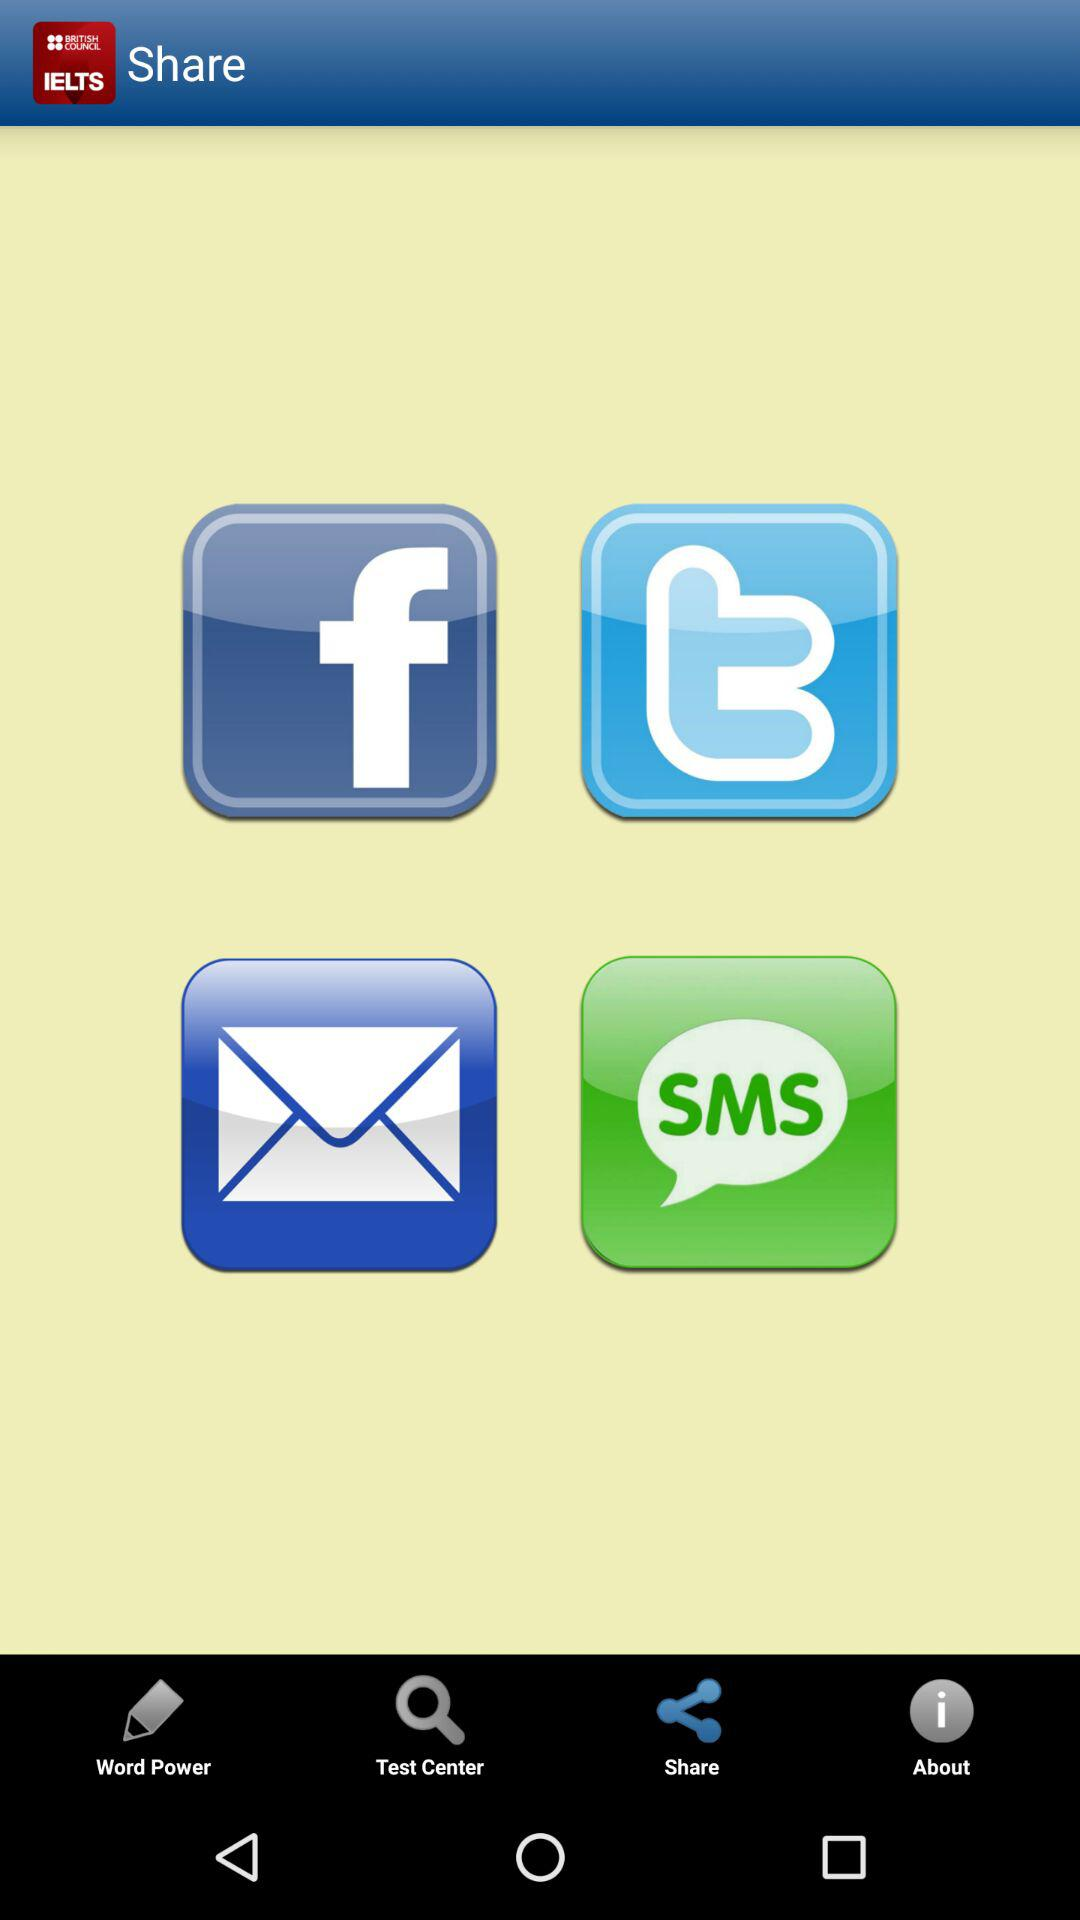Which tab is selected? The selected tab is "Share". 